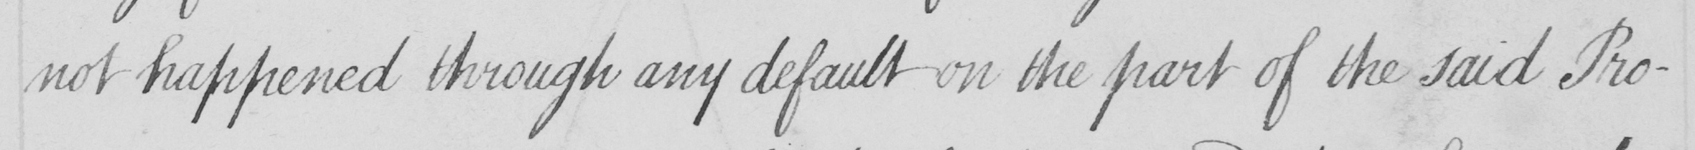Can you tell me what this handwritten text says? not happened through any default on the part of the said Pro- 